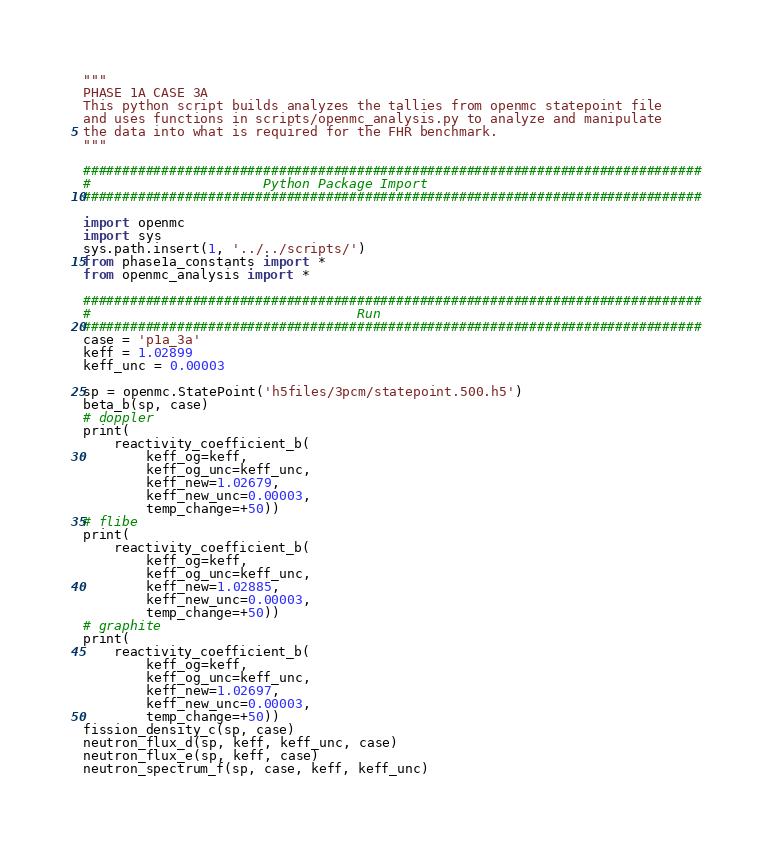<code> <loc_0><loc_0><loc_500><loc_500><_Python_>"""
PHASE 1A CASE 3A
This python script builds analyzes the tallies from openmc statepoint file
and uses functions in scripts/openmc_analysis.py to analyze and manipulate
the data into what is required for the FHR benchmark.
"""

###############################################################################
#                      Python Package Import
###############################################################################

import openmc
import sys
sys.path.insert(1, '../../scripts/')
from phase1a_constants import *
from openmc_analysis import *

###############################################################################
#                                  Run
###############################################################################
case = 'p1a_3a'
keff = 1.02899
keff_unc = 0.00003

sp = openmc.StatePoint('h5files/3pcm/statepoint.500.h5')
beta_b(sp, case)
# doppler
print(
    reactivity_coefficient_b(
        keff_og=keff,
        keff_og_unc=keff_unc,
        keff_new=1.02679,
        keff_new_unc=0.00003,
        temp_change=+50))
# flibe
print(
    reactivity_coefficient_b(
        keff_og=keff,
        keff_og_unc=keff_unc,
        keff_new=1.02885,
        keff_new_unc=0.00003,
        temp_change=+50))
# graphite
print(
    reactivity_coefficient_b(
        keff_og=keff,
        keff_og_unc=keff_unc,
        keff_new=1.02697,
        keff_new_unc=0.00003,
        temp_change=+50))
fission_density_c(sp, case)
neutron_flux_d(sp, keff, keff_unc, case)
neutron_flux_e(sp, keff, case)
neutron_spectrum_f(sp, case, keff, keff_unc)
</code> 